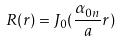Convert formula to latex. <formula><loc_0><loc_0><loc_500><loc_500>R ( r ) = J _ { 0 } ( \frac { \alpha _ { 0 n } } { a } r )</formula> 